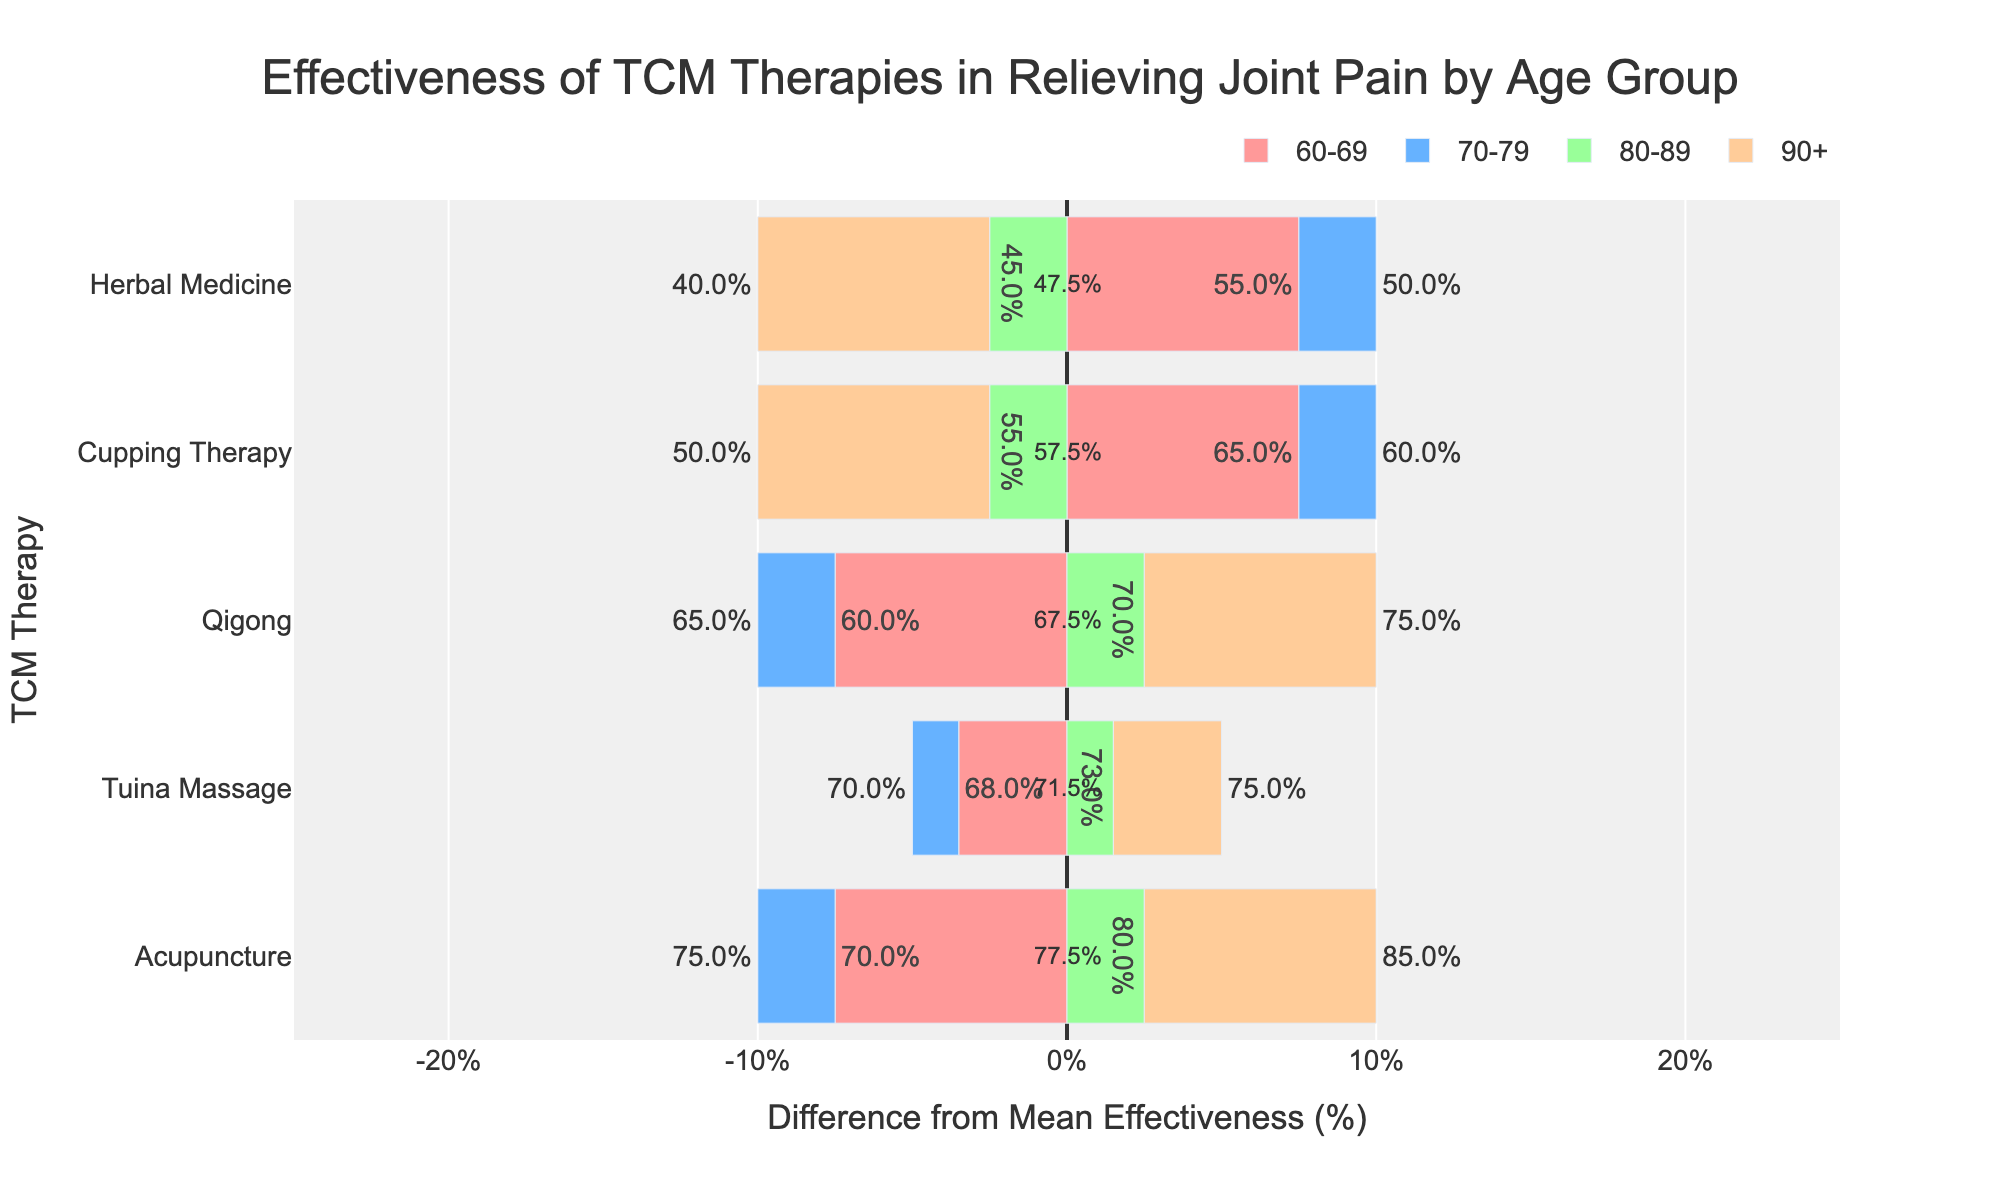What's the mean effectiveness of Acupuncture for all age groups? To find the mean effectiveness, add the percentages of each age group for Acupuncture (70 + 75 + 80 + 85) and divide by the number of age groups (4). This results in a mean effectiveness of (70 + 75 + 80 + 85) / 4 = 77.5%.
Answer: 77.5% Which age group finds Tuina Massage the most effective? Look at the bars for Tuina Massage across all age groups and identify the one with the highest value. The values are: 68% (60-69), 70% (70-79), 73% (80-89), 75% (90+). The highest value is 75% for the 90+ age group.
Answer: 90+ What's the difference in effectiveness between Acupuncture and Herbal Medicine for the 80-89 age group? For the 80-89 age group, the effectiveness of Acupuncture is 80% and for Herbal Medicine, it is 45%. The difference is 80 - 45 = 35%.
Answer: 35% Which therapy has the smallest difference from its mean effectiveness for the 70-79 age group? Check the bar lengths (difference from mean) for the 70-79 age group across all therapies. The values, relative to their means, are: Acupuncture (75 - 77.5 = -2.5), Cupping Therapy (60 - 57.5 = 2.5), Herbal Medicine (50 - 47.5 = 2.5), Qigong (65 - 62.5 = 2.5), Tuina Massage (70 - 71.5 = -1.5). The smallest absolute difference from the mean is Tuina Massage with -1.5.
Answer: Tuina Massage What is the mean effectiveness across all therapies for the 60-69 age group? Add the effectiveness percentages for all therapies (Acupuncture 70, Cupping Therapy 65, Herbal Medicine 55, Qigong 60, Tuina Massage 68) and divide by the number of therapies (5). The mean effectiveness is (70 + 65 + 55 + 60 + 68) / 5 = 63.6%.
Answer: 63.6% Which therapy shows the greatest improvement in effectiveness with increasing age groups? Compare the effectiveness percentages across age groups for each therapy. The therapy showing the greatest increase is Acupuncture, increasing from 70% (60-69) to 85% (90+).
Answer: Acupuncture For the 90+ age group, which therapy has the effectiveness closest to the mean effectiveness of Acupuncture? The mean effectiveness of Acupuncture is 77.5%. For the 90+ age group: Acupuncture (85%), Cupping Therapy (50%), Herbal Medicine (40%), Qigong (75%), Tuina Massage (75%). The closest value to 77.5% is the effectiveness of Qigong and Tuina Massage, both at 75%.
Answer: Qigong and Tuina Massage 